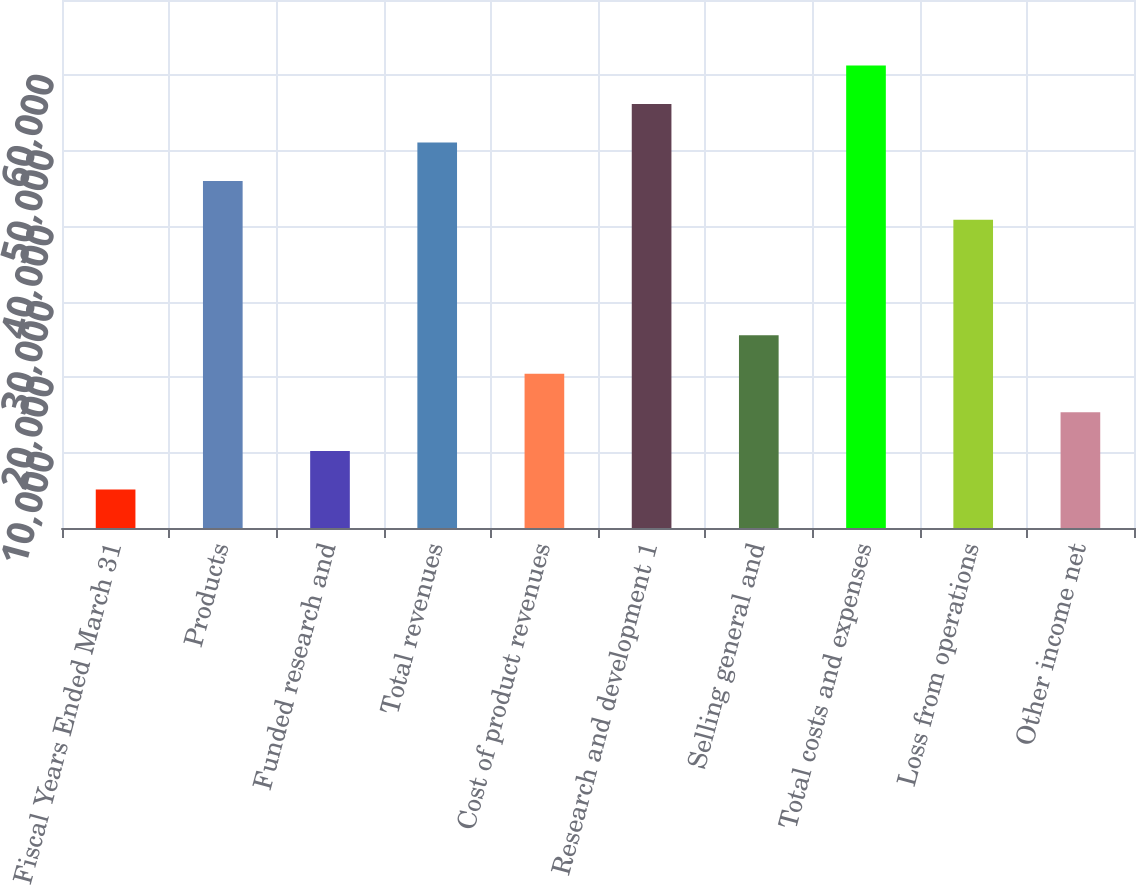Convert chart. <chart><loc_0><loc_0><loc_500><loc_500><bar_chart><fcel>Fiscal Years Ended March 31<fcel>Products<fcel>Funded research and<fcel>Total revenues<fcel>Cost of product revenues<fcel>Research and development 1<fcel>Selling general and<fcel>Total costs and expenses<fcel>Loss from operations<fcel>Other income net<nl><fcel>5110.82<fcel>45989.2<fcel>10220.6<fcel>51099<fcel>20440.2<fcel>56208.8<fcel>25550<fcel>61318.6<fcel>40879.4<fcel>15330.4<nl></chart> 